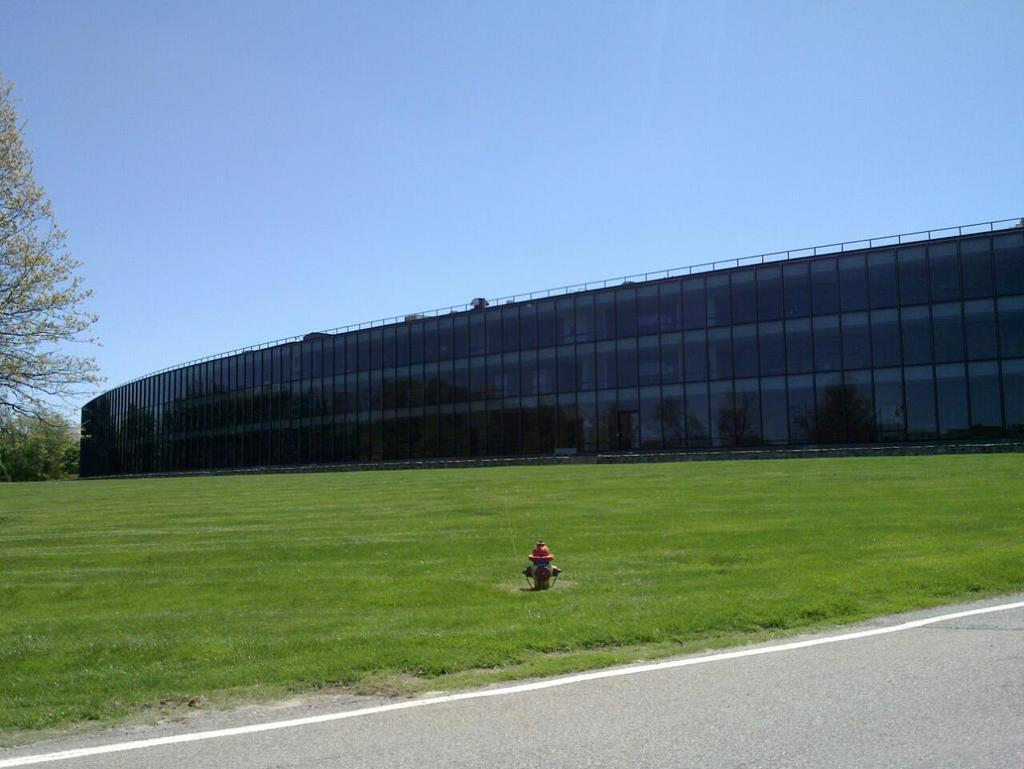What is the main feature of the image? There is a road in the image. What can be seen beside the road? There is grass beside the road. What object is placed on the grass? A fire hydrant is placed on the grass. What type of vegetation is present in the grass? There are trees in the grass. What structure is visible in the image? There is a building visible in the image. What is visible at the top of the image? The sky is visible at the top of the image. Can you see a yoke being used by the trees in the image? There is no yoke present in the image, and trees do not use yokes. How many arms are visible on the fire hydrant in the image? Fire hydrants do not have arms; they are stationary objects with no limbs or appendages. 